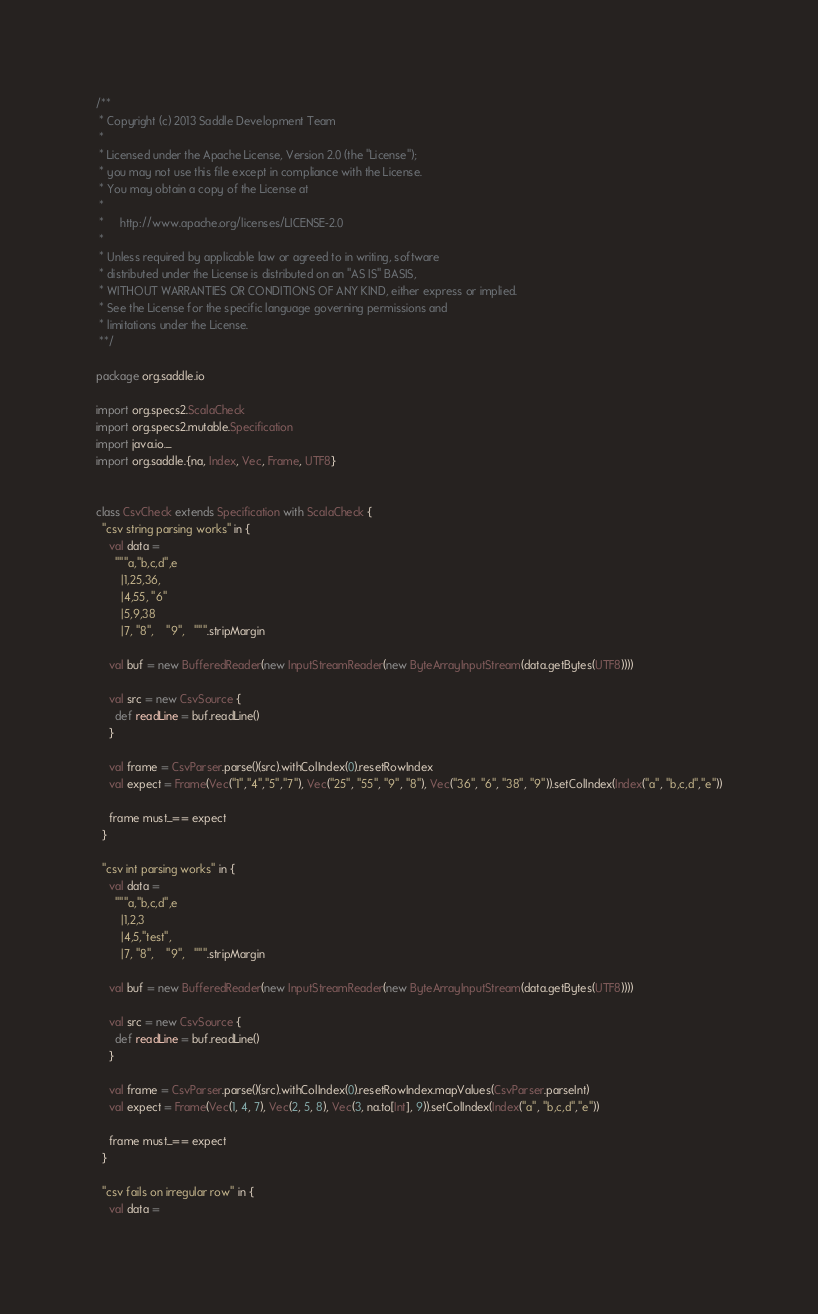<code> <loc_0><loc_0><loc_500><loc_500><_Scala_>/**
 * Copyright (c) 2013 Saddle Development Team
 *
 * Licensed under the Apache License, Version 2.0 (the "License");
 * you may not use this file except in compliance with the License.
 * You may obtain a copy of the License at
 *
 *     http://www.apache.org/licenses/LICENSE-2.0
 *
 * Unless required by applicable law or agreed to in writing, software
 * distributed under the License is distributed on an "AS IS" BASIS,
 * WITHOUT WARRANTIES OR CONDITIONS OF ANY KIND, either express or implied.
 * See the License for the specific language governing permissions and
 * limitations under the License.
 **/

package org.saddle.io

import org.specs2.ScalaCheck
import org.specs2.mutable.Specification
import java.io._
import org.saddle.{na, Index, Vec, Frame, UTF8}


class CsvCheck extends Specification with ScalaCheck {
  "csv string parsing works" in {
    val data =
      """a,"b,c,d",e
        |1,25,36,
        |4,55, "6"
        |5,9,38
        |7, "8",    "9",   """.stripMargin

    val buf = new BufferedReader(new InputStreamReader(new ByteArrayInputStream(data.getBytes(UTF8))))

    val src = new CsvSource {
      def readLine = buf.readLine()
    }

    val frame = CsvParser.parse()(src).withColIndex(0).resetRowIndex
    val expect = Frame(Vec("1","4","5","7"), Vec("25", "55", "9", "8"), Vec("36", "6", "38", "9")).setColIndex(Index("a", "b,c,d","e"))

    frame must_== expect
  }

  "csv int parsing works" in {
    val data =
      """a,"b,c,d",e
        |1,2,3
        |4,5,"test",
        |7, "8",    "9",   """.stripMargin

    val buf = new BufferedReader(new InputStreamReader(new ByteArrayInputStream(data.getBytes(UTF8))))

    val src = new CsvSource {
      def readLine = buf.readLine()
    }

    val frame = CsvParser.parse()(src).withColIndex(0).resetRowIndex.mapValues(CsvParser.parseInt)
    val expect = Frame(Vec(1, 4, 7), Vec(2, 5, 8), Vec(3, na.to[Int], 9)).setColIndex(Index("a", "b,c,d","e"))

    frame must_== expect
  }

  "csv fails on irregular row" in {
    val data =</code> 